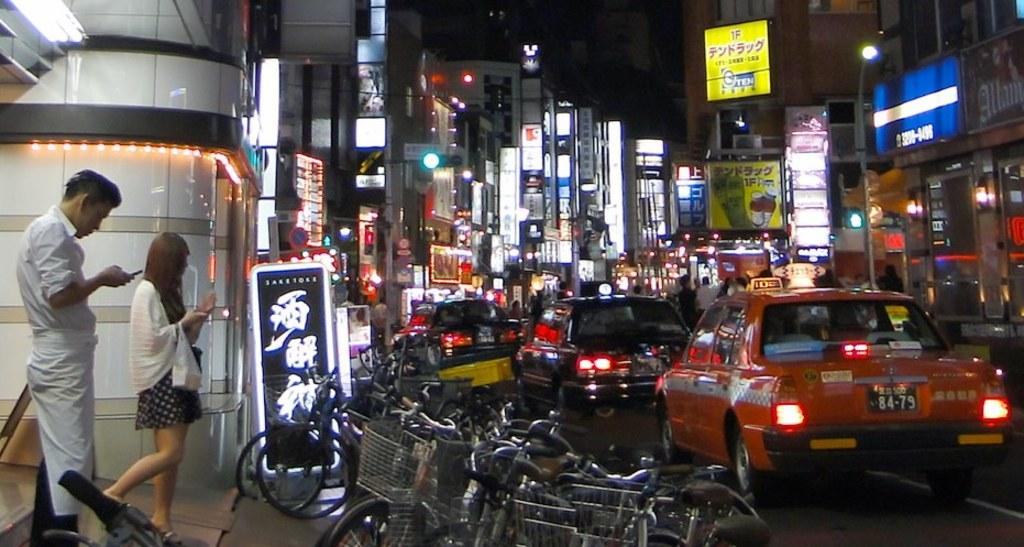<image>
Relay a brief, clear account of the picture shown. A couple is looking at their phones next to a busy street containing a taxi with the license plate number 84-79. 